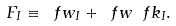<formula> <loc_0><loc_0><loc_500><loc_500>F _ { I } \equiv \ f w _ { I } + \ f w \ f k _ { I } .</formula> 